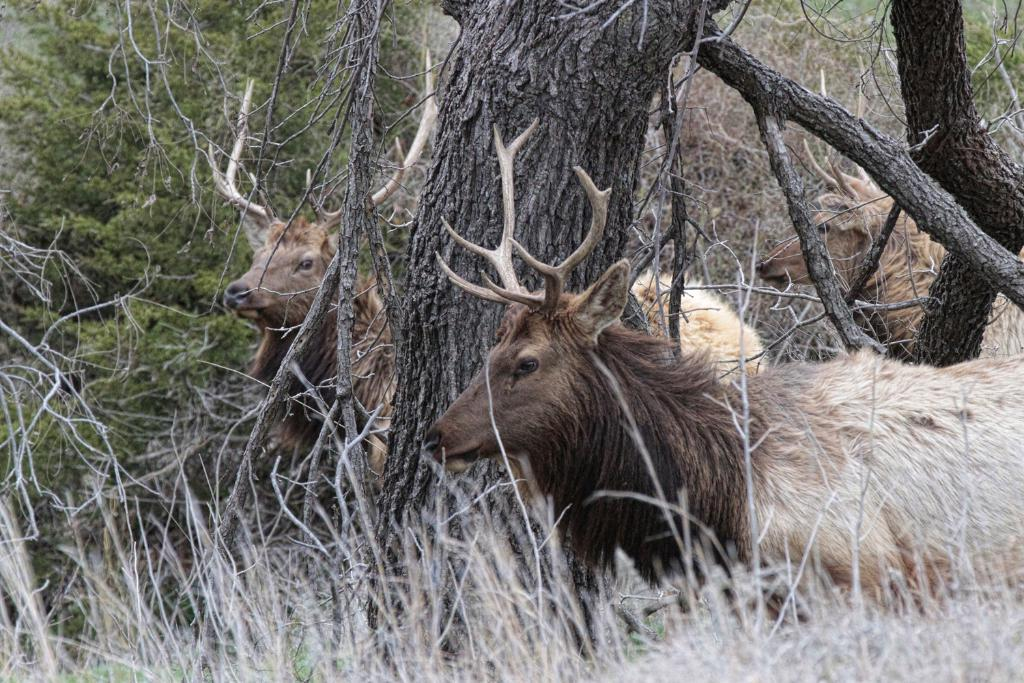What type of living organisms can be seen on the ground in the image? There are animals on the ground in the image. What feature of the trees can be observed in the image? The bark of trees is visible in the image. What type of vegetation is present in the image? There are plants in the image. What type of large vegetation is present in the image? There are trees in the image. What type of butter can be seen on the nose of the animals in the image? There is no butter present on the animals' noses in the image. How does the rain affect the plants in the image? There is no rain present in the image, so its effect on the plants cannot be determined. 